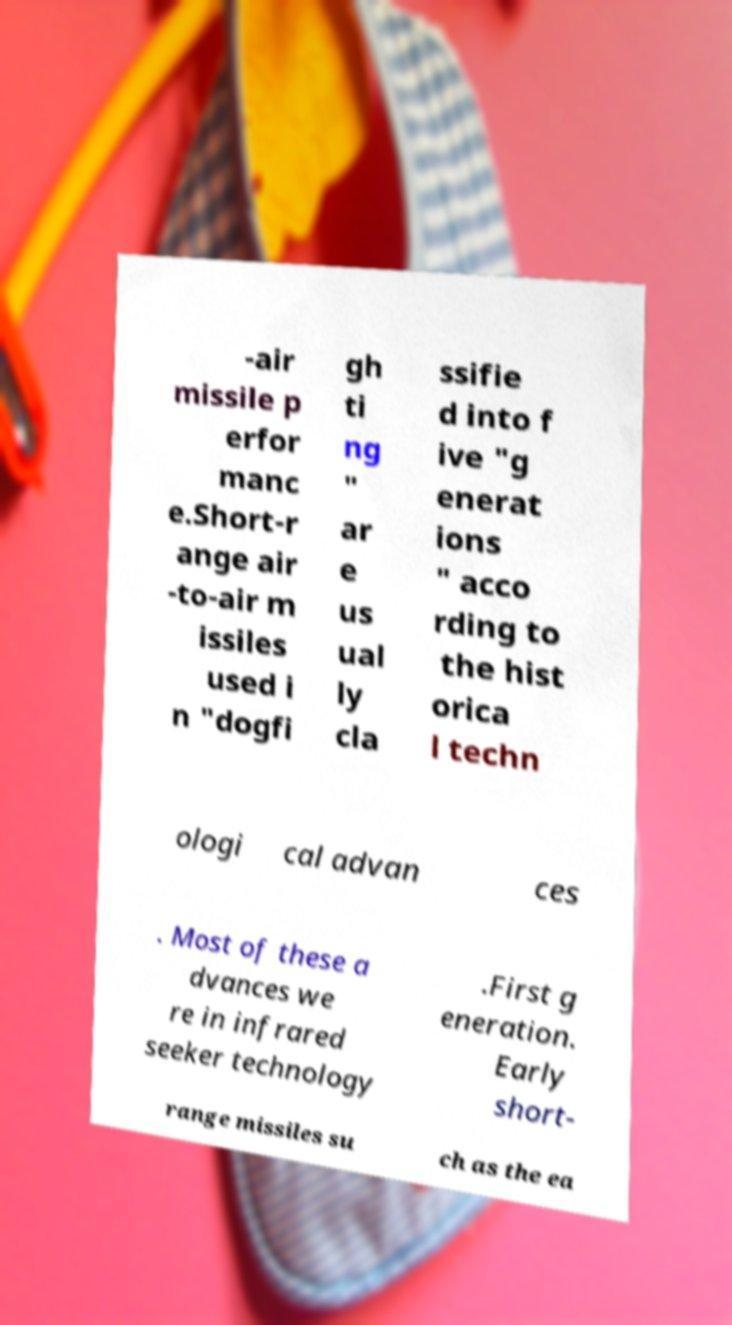Please identify and transcribe the text found in this image. -air missile p erfor manc e.Short-r ange air -to-air m issiles used i n "dogfi gh ti ng " ar e us ual ly cla ssifie d into f ive "g enerat ions " acco rding to the hist orica l techn ologi cal advan ces . Most of these a dvances we re in infrared seeker technology .First g eneration. Early short- range missiles su ch as the ea 